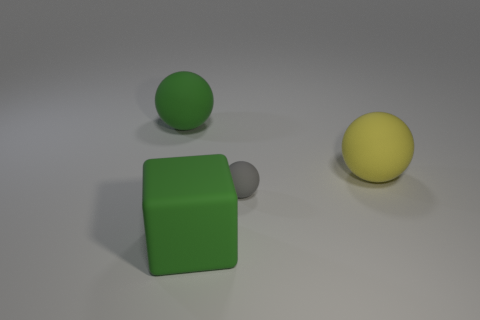Subtract all large matte spheres. How many spheres are left? 1 Add 4 small objects. How many objects exist? 8 Subtract all gray balls. How many balls are left? 2 Subtract 2 balls. How many balls are left? 1 Subtract 0 blue cubes. How many objects are left? 4 Subtract all spheres. How many objects are left? 1 Subtract all brown balls. Subtract all red cylinders. How many balls are left? 3 Subtract all cyan cylinders. How many yellow balls are left? 1 Subtract all tiny gray objects. Subtract all cyan matte objects. How many objects are left? 3 Add 3 large yellow things. How many large yellow things are left? 4 